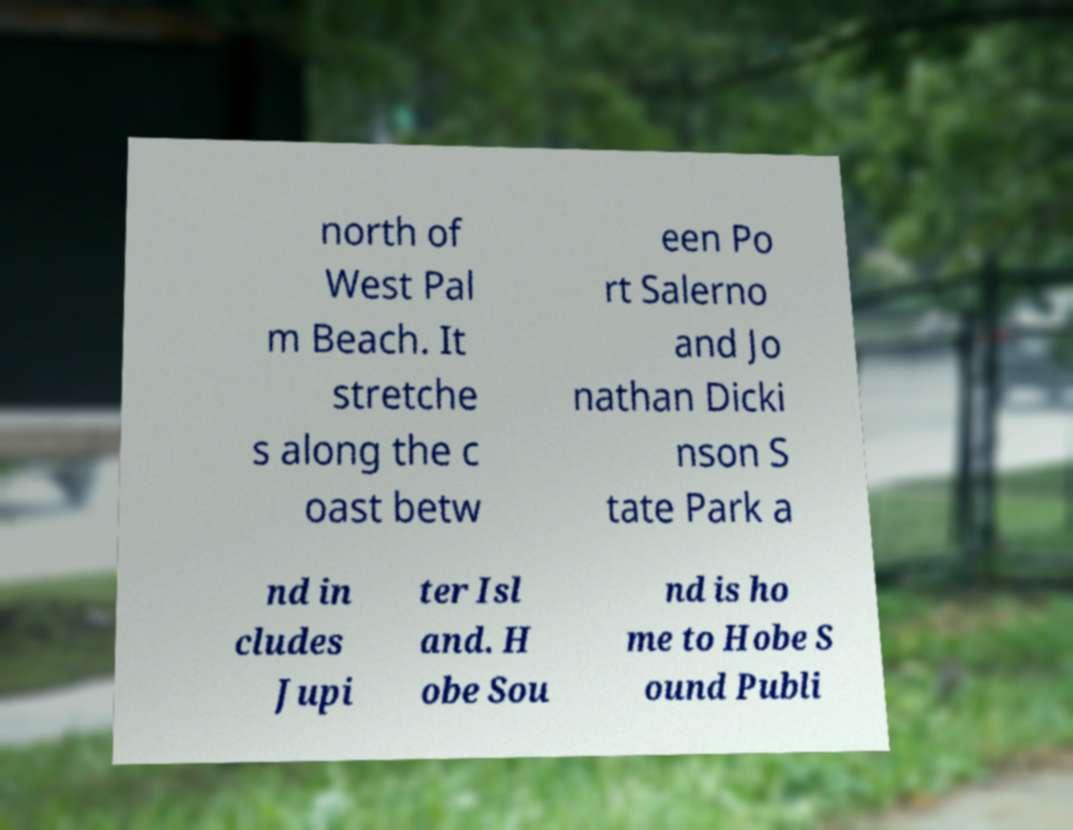Please read and relay the text visible in this image. What does it say? north of West Pal m Beach. It stretche s along the c oast betw een Po rt Salerno and Jo nathan Dicki nson S tate Park a nd in cludes Jupi ter Isl and. H obe Sou nd is ho me to Hobe S ound Publi 